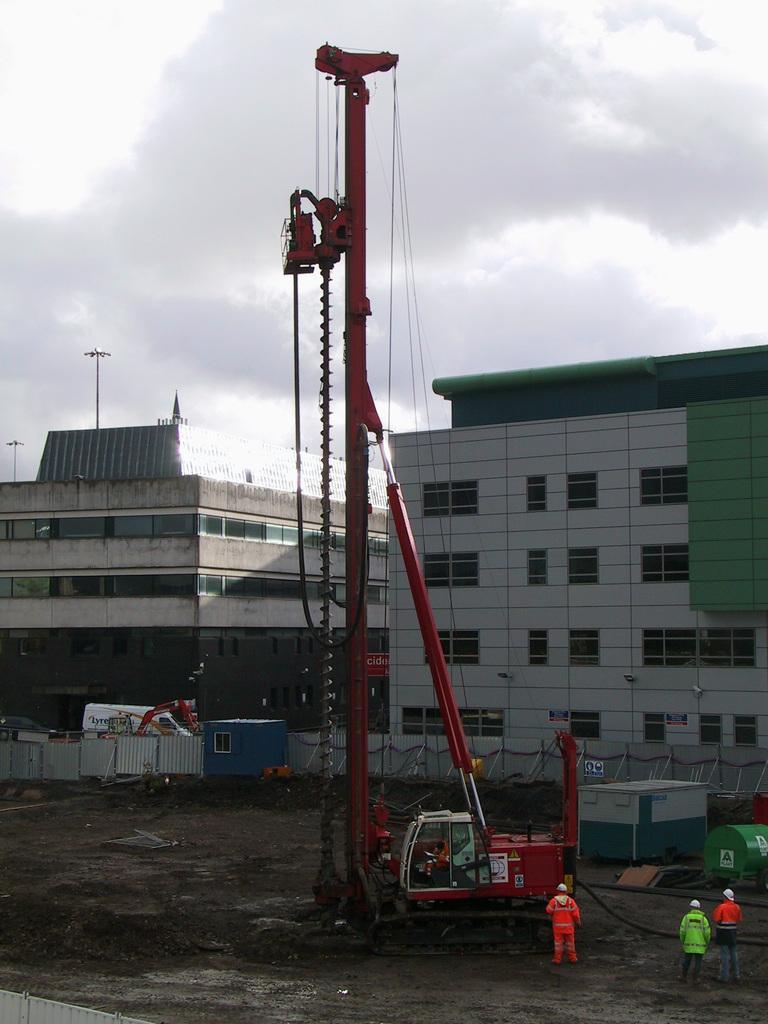Describe this image in one or two sentences. Here we can see vehicles and three persons. In the background there are buildings, poles, and sky with clouds. 